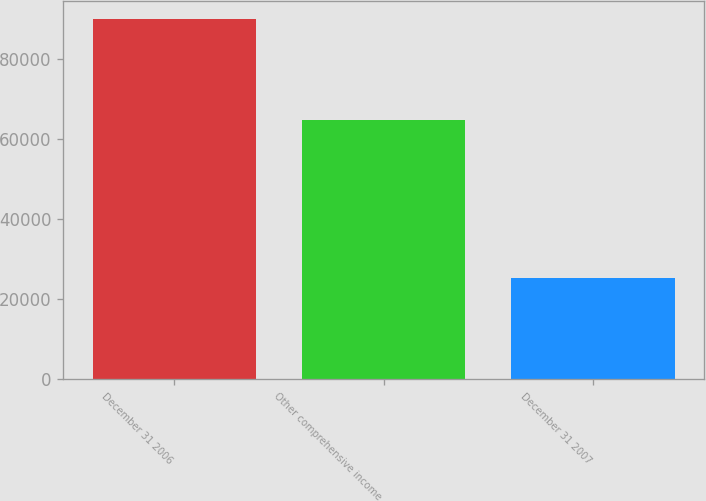<chart> <loc_0><loc_0><loc_500><loc_500><bar_chart><fcel>December 31 2006<fcel>Other comprehensive income<fcel>December 31 2007<nl><fcel>89971<fcel>64643<fcel>25328<nl></chart> 